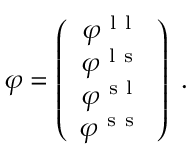<formula> <loc_0><loc_0><loc_500><loc_500>\begin{array} { r } { \varphi = \left ( \begin{array} { c } { \varphi ^ { l l } } \\ { \varphi ^ { l s } } \\ { \varphi ^ { s l } } \\ { \varphi ^ { s s } } \end{array} \right ) \, . } \end{array}</formula> 